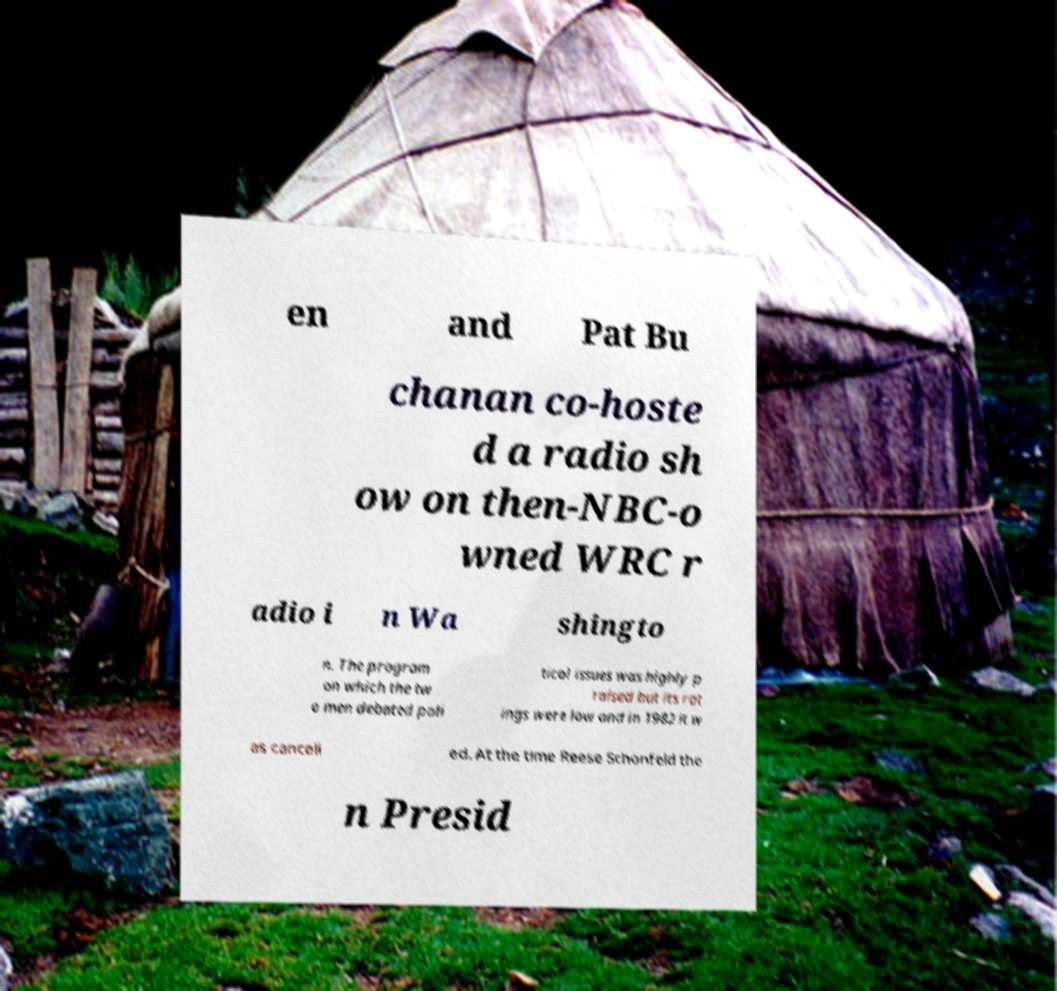Please read and relay the text visible in this image. What does it say? en and Pat Bu chanan co-hoste d a radio sh ow on then-NBC-o wned WRC r adio i n Wa shingto n. The program on which the tw o men debated poli tical issues was highly p raised but its rat ings were low and in 1982 it w as cancell ed. At the time Reese Schonfeld the n Presid 